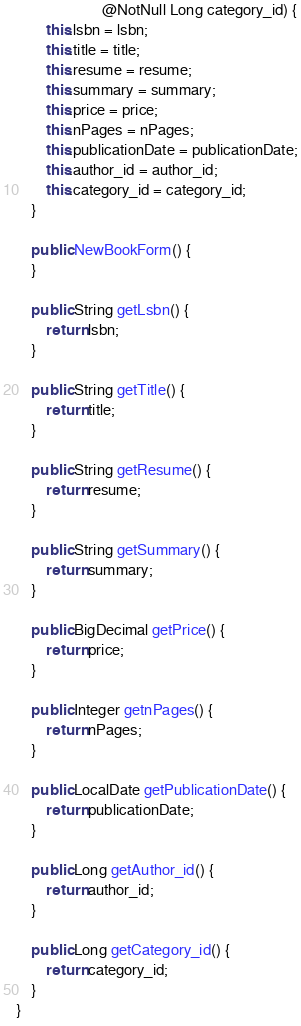Convert code to text. <code><loc_0><loc_0><loc_500><loc_500><_Java_>                       @NotNull Long category_id) {
        this.lsbn = lsbn;
        this.title = title;
        this.resume = resume;
        this.summary = summary;
        this.price = price;
        this.nPages = nPages;
        this.publicationDate = publicationDate;
        this.author_id = author_id;
        this.category_id = category_id;
    }

    public NewBookForm() {
    }

    public String getLsbn() {
        return lsbn;
    }

    public String getTitle() {
        return title;
    }

    public String getResume() {
        return resume;
    }

    public String getSummary() {
        return summary;
    }

    public BigDecimal getPrice() {
        return price;
    }

    public Integer getnPages() {
        return nPages;
    }

    public LocalDate getPublicationDate() {
        return publicationDate;
    }

    public Long getAuthor_id() {
        return author_id;
    }

    public Long getCategory_id() {
        return category_id;
    }
}
</code> 